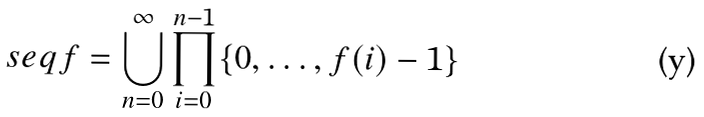<formula> <loc_0><loc_0><loc_500><loc_500>\ s e q f = \bigcup _ { n = 0 } ^ { \infty } \prod _ { i = 0 } ^ { n - 1 } \{ 0 , \dots , f ( i ) - 1 \}</formula> 